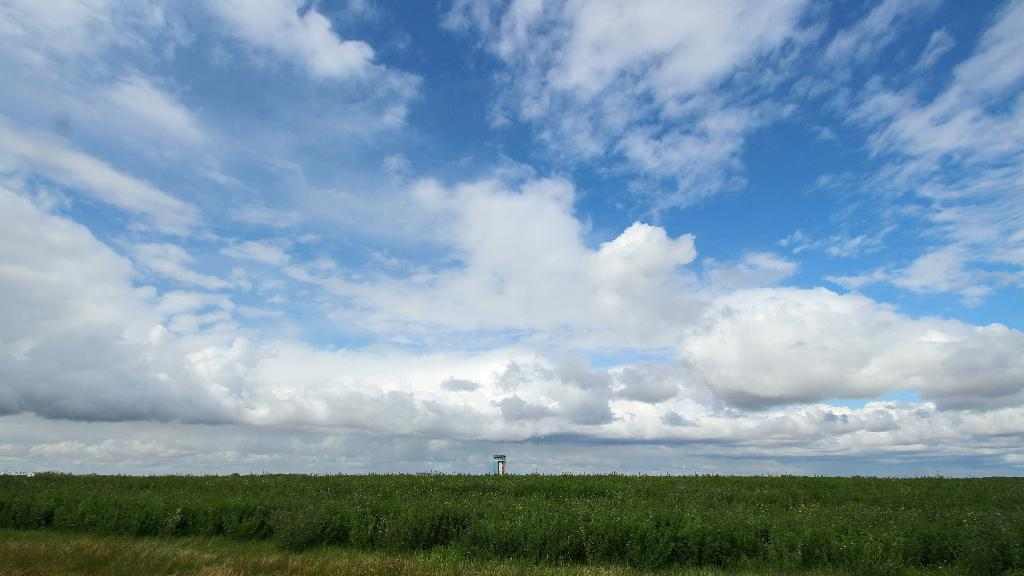What type of landscape is visible in the image? There are green fields on the ground in the image. What can be seen in the middle of the image? There is an object in the middle of the image. What is visible in the background of the image? The sky is visible in the background of the image. How would you describe the sky in the image? The sky appears to be cloudy. What type of owl can be seen perched on the object in the image? There is no owl present in the image; it only features green fields, an object, and a cloudy sky. How does the acoustics of the image affect the sound of the wind? The image does not provide any information about the acoustics or the sound of the wind, as it only shows a visual representation of the scene. 